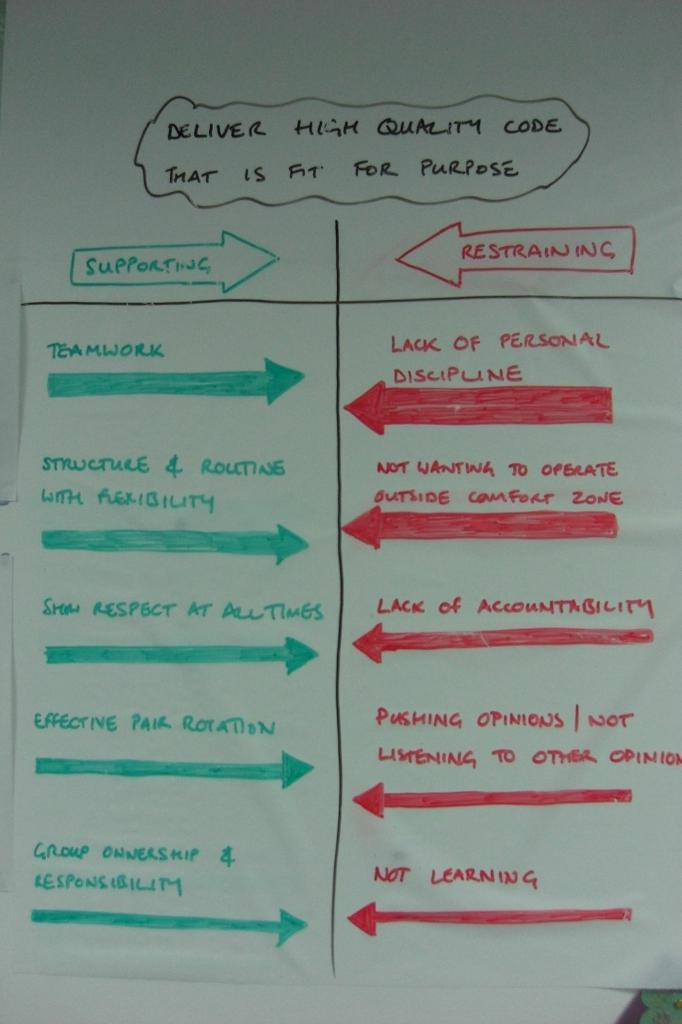<image>
Create a compact narrative representing the image presented. A white board has a lot of writing and says Delivery High Quality Code That is Fit For Purpose. 